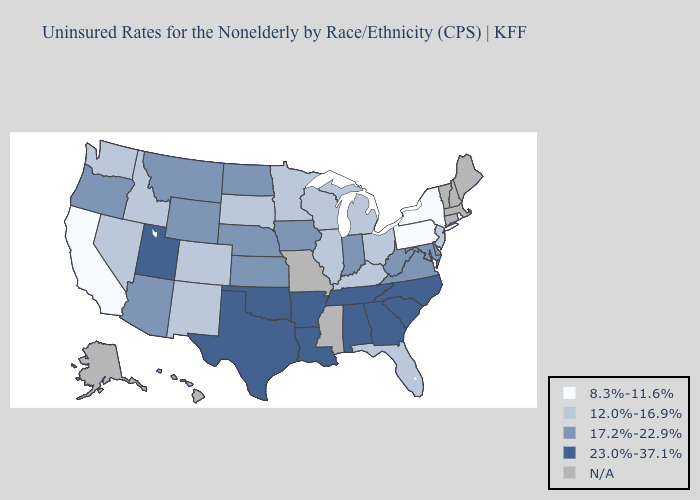Name the states that have a value in the range 23.0%-37.1%?
Quick response, please. Alabama, Arkansas, Georgia, Louisiana, North Carolina, Oklahoma, South Carolina, Tennessee, Texas, Utah. Name the states that have a value in the range 8.3%-11.6%?
Answer briefly. California, New York, Pennsylvania, Rhode Island. What is the lowest value in states that border Michigan?
Be succinct. 12.0%-16.9%. Name the states that have a value in the range 17.2%-22.9%?
Keep it brief. Arizona, Delaware, Indiana, Iowa, Kansas, Maryland, Montana, Nebraska, North Dakota, Oregon, Virginia, West Virginia, Wyoming. Name the states that have a value in the range 12.0%-16.9%?
Keep it brief. Colorado, Florida, Idaho, Illinois, Kentucky, Michigan, Minnesota, Nevada, New Jersey, New Mexico, Ohio, South Dakota, Washington, Wisconsin. How many symbols are there in the legend?
Give a very brief answer. 5. What is the value of West Virginia?
Short answer required. 17.2%-22.9%. Which states have the lowest value in the USA?
Write a very short answer. California, New York, Pennsylvania, Rhode Island. What is the lowest value in the USA?
Short answer required. 8.3%-11.6%. What is the lowest value in the West?
Be succinct. 8.3%-11.6%. Does New York have the lowest value in the USA?
Concise answer only. Yes. Which states have the highest value in the USA?
Be succinct. Alabama, Arkansas, Georgia, Louisiana, North Carolina, Oklahoma, South Carolina, Tennessee, Texas, Utah. What is the value of Texas?
Be succinct. 23.0%-37.1%. What is the lowest value in the South?
Write a very short answer. 12.0%-16.9%. Which states have the lowest value in the South?
Short answer required. Florida, Kentucky. 